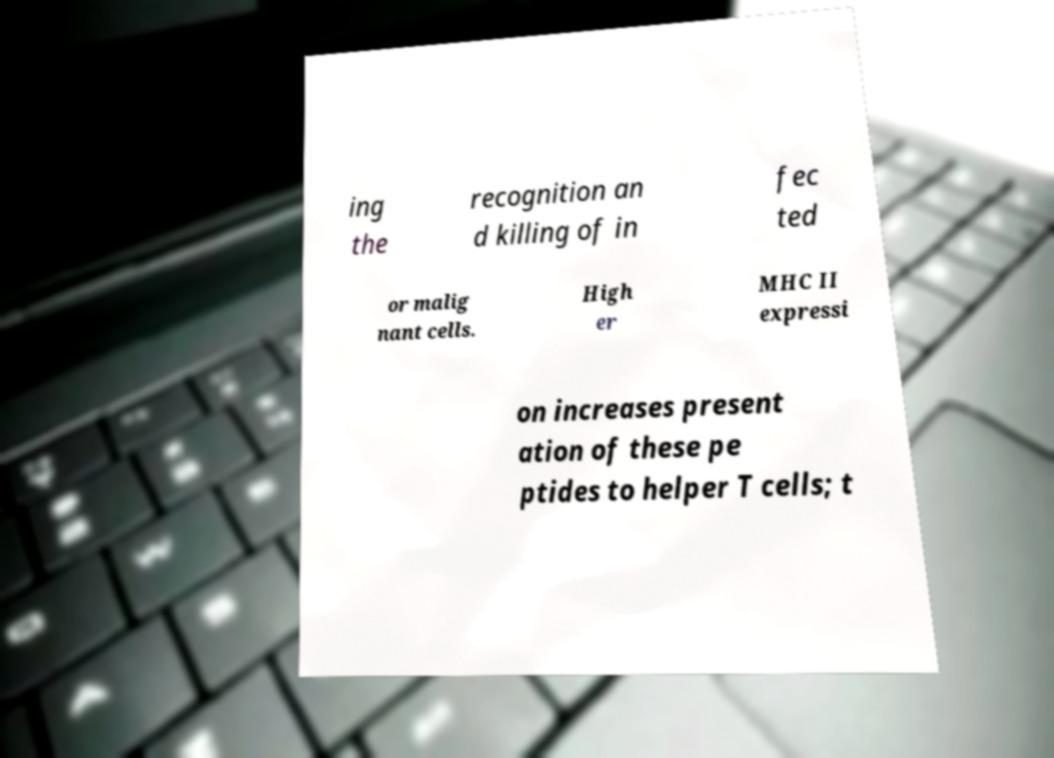What messages or text are displayed in this image? I need them in a readable, typed format. ing the recognition an d killing of in fec ted or malig nant cells. High er MHC II expressi on increases present ation of these pe ptides to helper T cells; t 